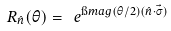Convert formula to latex. <formula><loc_0><loc_0><loc_500><loc_500>R _ { \hat { n } } ( \theta ) = \ e ^ { \i m a g ( \theta / 2 ) ( \hat { n } \cdot \vec { \sigma } ) }</formula> 